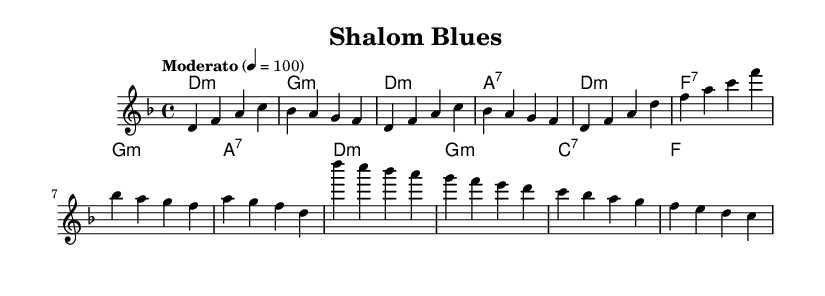What is the key signature of this music? The key signature indicated is D minor, as it appears at the beginning of the sheet music and reflects the tonal center of the melody and harmonies.
Answer: D minor What is the time signature of this music? The time signature is 4/4, which is noted at the beginning of the sheet music. This means there are four beats per measure and the quarter note gets one beat.
Answer: 4/4 What is the tempo marking of this piece? The tempo marking is "Moderato" followed by a beats-per-minute indication of 100, indicating a moderate speed for the performance.
Answer: Moderato 4 = 100 How many measures are in the introduction? The introduction contains four measures, as counted from the notated section specifically labeled as the intro before the verse starts.
Answer: 4 Which chord is played in the last measure of the chorus? The last measure of the chorus is an F chord, as indicated in the harmony section.
Answer: F What chord follows the D minor chord in the verse? The chord following the D minor chord in the verse is an F7 chord, which is the second chord indicated in the verse section of the harmonies.
Answer: F7 How does the melody relate to the traditional Klezmer influence? The melody incorporates distinctive blues elements while intertwining with traditional klezmer motifs, characterized by expressive pitches and rhythmic phrasing typical of Jewish folk music, blending the feel of both styles.
Answer: Blues and Klezmer Fusion 